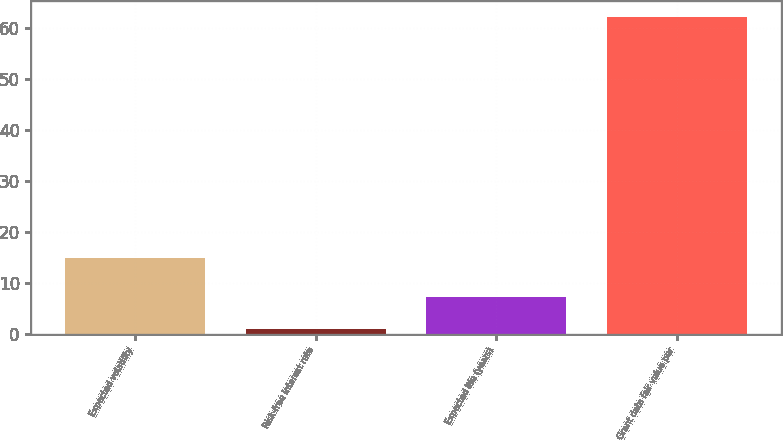Convert chart to OTSL. <chart><loc_0><loc_0><loc_500><loc_500><bar_chart><fcel>Expected volatility<fcel>Risk-free interest rate<fcel>Expected life (years)<fcel>Grant date fair value per<nl><fcel>14.93<fcel>1.07<fcel>7.17<fcel>62.1<nl></chart> 